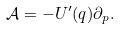<formula> <loc_0><loc_0><loc_500><loc_500>\mathcal { A } = - U ^ { \prime } ( q ) \partial _ { p } .</formula> 